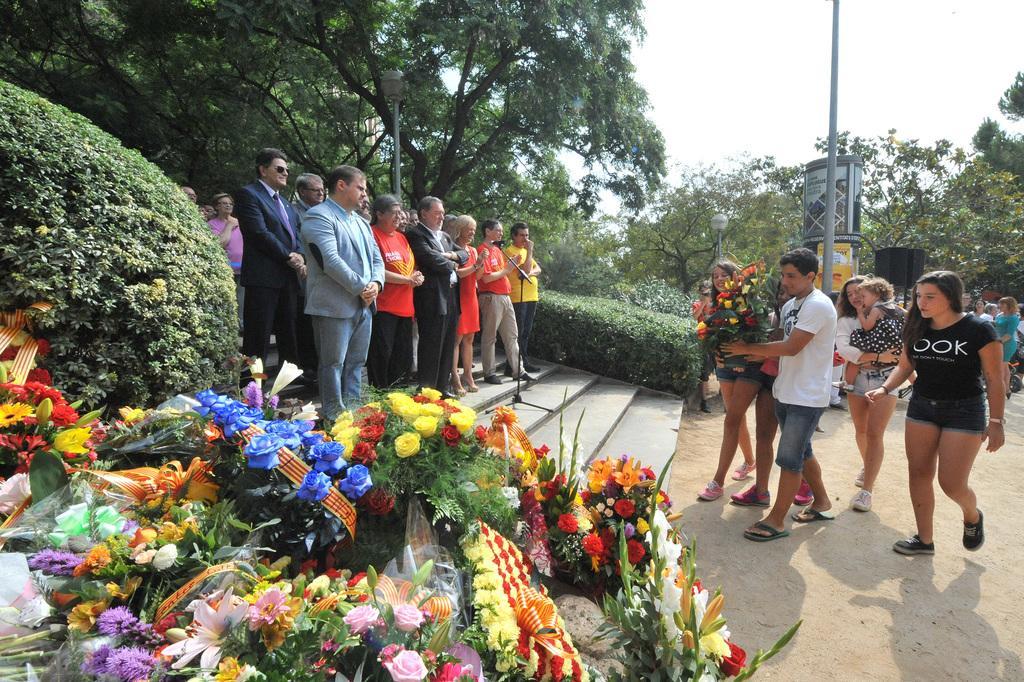How would you summarize this image in a sentence or two? There are group of people standing on the stairs. This looks like a mike with the mike stand. I can see the man and woman holding a flower bouquet and walking. These are the bushes. I can see a bunch of colorful flower bouquets. These are the trees. This looks like a street light. I can see few people walking. 